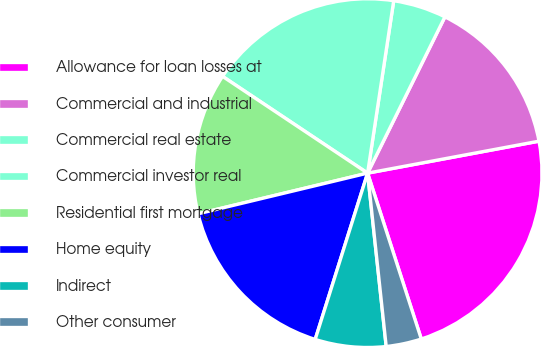Convert chart to OTSL. <chart><loc_0><loc_0><loc_500><loc_500><pie_chart><fcel>Allowance for loan losses at<fcel>Commercial and industrial<fcel>Commercial real estate<fcel>Commercial investor real<fcel>Residential first mortgage<fcel>Home equity<fcel>Indirect<fcel>Other consumer<nl><fcel>22.95%<fcel>14.75%<fcel>4.92%<fcel>18.03%<fcel>13.11%<fcel>16.39%<fcel>6.56%<fcel>3.28%<nl></chart> 